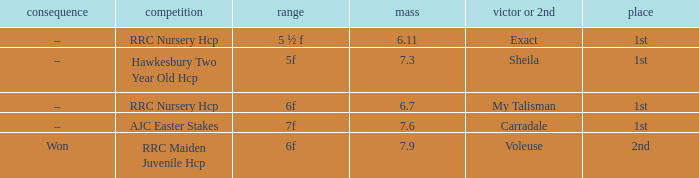What is the the name of the winner or 2nd  with a weight more than 7.3, and the result was –? Carradale. 